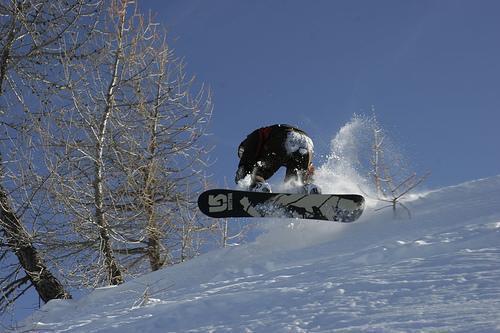How many people are there?
Give a very brief answer. 1. How many people are airborne?
Give a very brief answer. 1. How many cars are parked on the street?
Give a very brief answer. 0. 